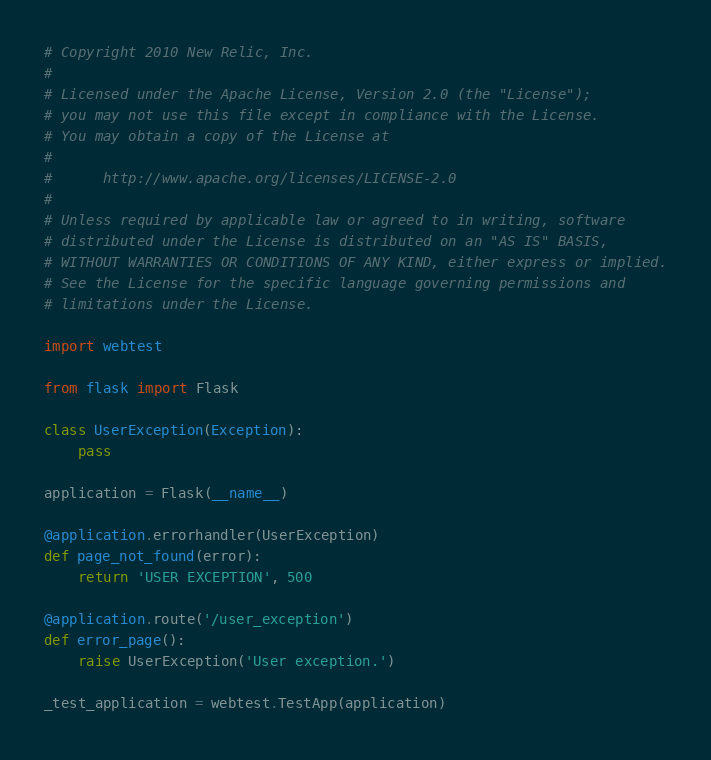Convert code to text. <code><loc_0><loc_0><loc_500><loc_500><_Python_># Copyright 2010 New Relic, Inc.
#
# Licensed under the Apache License, Version 2.0 (the "License");
# you may not use this file except in compliance with the License.
# You may obtain a copy of the License at
#
#      http://www.apache.org/licenses/LICENSE-2.0
#
# Unless required by applicable law or agreed to in writing, software
# distributed under the License is distributed on an "AS IS" BASIS,
# WITHOUT WARRANTIES OR CONDITIONS OF ANY KIND, either express or implied.
# See the License for the specific language governing permissions and
# limitations under the License.

import webtest

from flask import Flask

class UserException(Exception):
    pass

application = Flask(__name__)

@application.errorhandler(UserException)
def page_not_found(error):
    return 'USER EXCEPTION', 500

@application.route('/user_exception')
def error_page():
    raise UserException('User exception.')

_test_application = webtest.TestApp(application)
</code> 